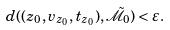Convert formula to latex. <formula><loc_0><loc_0><loc_500><loc_500>d ( ( z _ { 0 } , v _ { z _ { 0 } } , t _ { z _ { 0 } } ) , \tilde { \mathcal { M } } _ { 0 } ) < \varepsilon .</formula> 